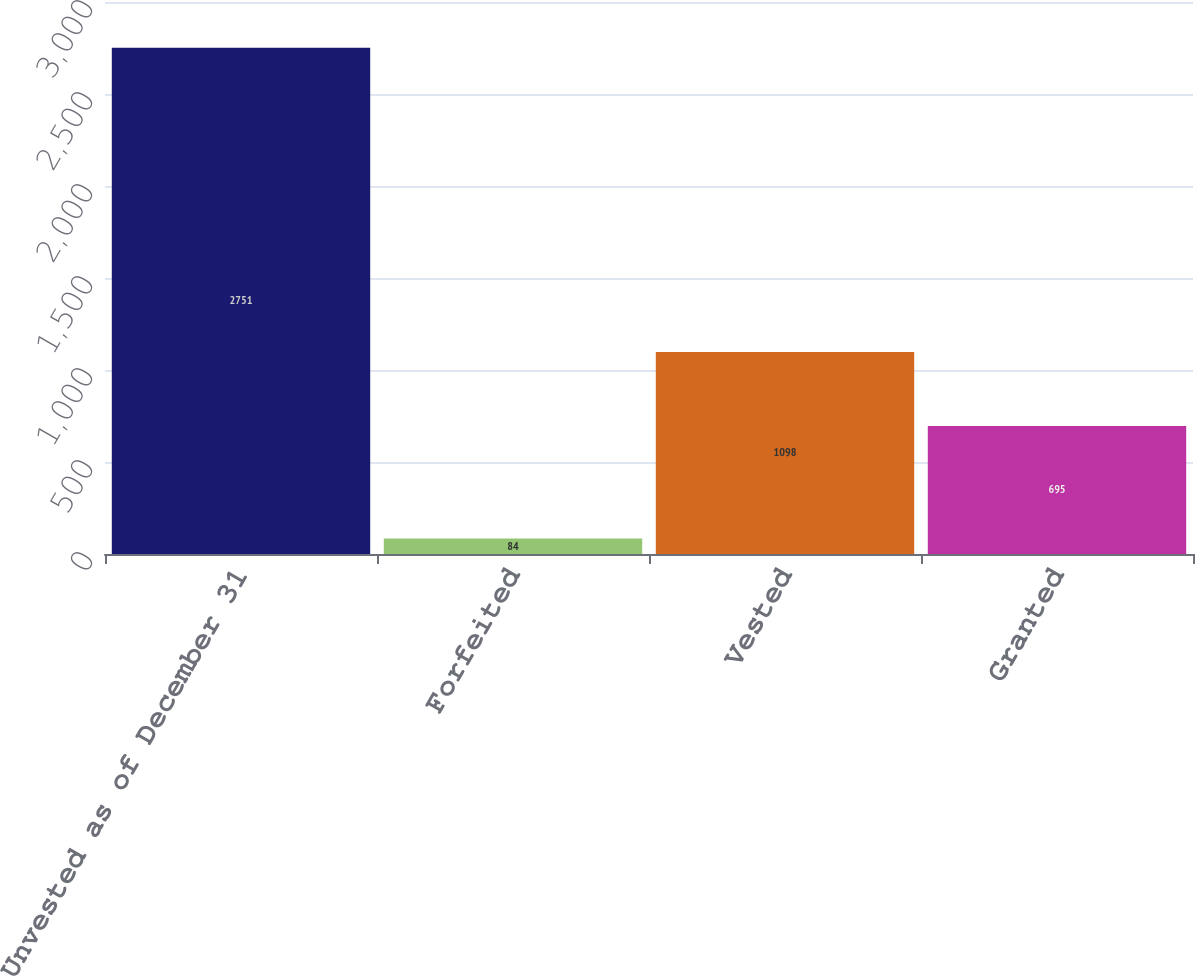Convert chart. <chart><loc_0><loc_0><loc_500><loc_500><bar_chart><fcel>Unvested as of December 31<fcel>Forfeited<fcel>Vested<fcel>Granted<nl><fcel>2751<fcel>84<fcel>1098<fcel>695<nl></chart> 